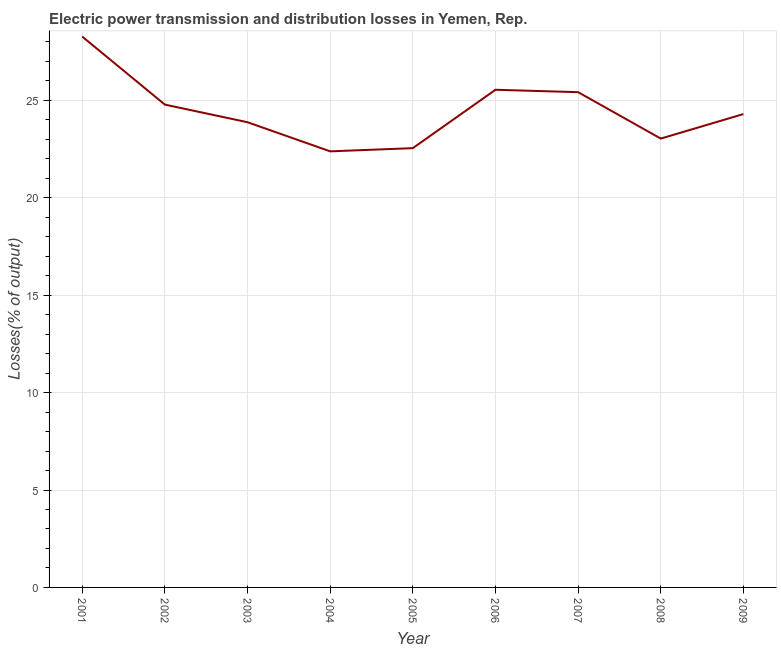What is the electric power transmission and distribution losses in 2003?
Your answer should be very brief. 23.88. Across all years, what is the maximum electric power transmission and distribution losses?
Provide a short and direct response. 28.27. Across all years, what is the minimum electric power transmission and distribution losses?
Offer a very short reply. 22.38. In which year was the electric power transmission and distribution losses minimum?
Your answer should be compact. 2004. What is the sum of the electric power transmission and distribution losses?
Make the answer very short. 220.15. What is the difference between the electric power transmission and distribution losses in 2002 and 2008?
Your response must be concise. 1.74. What is the average electric power transmission and distribution losses per year?
Provide a succinct answer. 24.46. What is the median electric power transmission and distribution losses?
Your answer should be very brief. 24.3. In how many years, is the electric power transmission and distribution losses greater than 19 %?
Provide a short and direct response. 9. What is the ratio of the electric power transmission and distribution losses in 2002 to that in 2006?
Your response must be concise. 0.97. What is the difference between the highest and the second highest electric power transmission and distribution losses?
Your answer should be very brief. 2.73. What is the difference between the highest and the lowest electric power transmission and distribution losses?
Keep it short and to the point. 5.89. In how many years, is the electric power transmission and distribution losses greater than the average electric power transmission and distribution losses taken over all years?
Keep it short and to the point. 4. Does the electric power transmission and distribution losses monotonically increase over the years?
Provide a short and direct response. No. How many lines are there?
Give a very brief answer. 1. How many years are there in the graph?
Your answer should be compact. 9. What is the difference between two consecutive major ticks on the Y-axis?
Your answer should be very brief. 5. Are the values on the major ticks of Y-axis written in scientific E-notation?
Provide a short and direct response. No. Does the graph contain any zero values?
Your response must be concise. No. What is the title of the graph?
Your answer should be compact. Electric power transmission and distribution losses in Yemen, Rep. What is the label or title of the Y-axis?
Give a very brief answer. Losses(% of output). What is the Losses(% of output) in 2001?
Ensure brevity in your answer.  28.27. What is the Losses(% of output) of 2002?
Provide a succinct answer. 24.78. What is the Losses(% of output) of 2003?
Your answer should be very brief. 23.88. What is the Losses(% of output) in 2004?
Keep it short and to the point. 22.38. What is the Losses(% of output) in 2005?
Keep it short and to the point. 22.55. What is the Losses(% of output) of 2006?
Provide a succinct answer. 25.54. What is the Losses(% of output) of 2007?
Provide a short and direct response. 25.42. What is the Losses(% of output) of 2008?
Offer a very short reply. 23.04. What is the Losses(% of output) of 2009?
Give a very brief answer. 24.3. What is the difference between the Losses(% of output) in 2001 and 2002?
Provide a succinct answer. 3.49. What is the difference between the Losses(% of output) in 2001 and 2003?
Offer a very short reply. 4.4. What is the difference between the Losses(% of output) in 2001 and 2004?
Your response must be concise. 5.89. What is the difference between the Losses(% of output) in 2001 and 2005?
Offer a very short reply. 5.73. What is the difference between the Losses(% of output) in 2001 and 2006?
Keep it short and to the point. 2.73. What is the difference between the Losses(% of output) in 2001 and 2007?
Provide a succinct answer. 2.85. What is the difference between the Losses(% of output) in 2001 and 2008?
Offer a very short reply. 5.24. What is the difference between the Losses(% of output) in 2001 and 2009?
Your answer should be compact. 3.98. What is the difference between the Losses(% of output) in 2002 and 2003?
Give a very brief answer. 0.9. What is the difference between the Losses(% of output) in 2002 and 2004?
Ensure brevity in your answer.  2.4. What is the difference between the Losses(% of output) in 2002 and 2005?
Provide a succinct answer. 2.23. What is the difference between the Losses(% of output) in 2002 and 2006?
Offer a very short reply. -0.76. What is the difference between the Losses(% of output) in 2002 and 2007?
Your answer should be very brief. -0.64. What is the difference between the Losses(% of output) in 2002 and 2008?
Provide a succinct answer. 1.74. What is the difference between the Losses(% of output) in 2002 and 2009?
Provide a succinct answer. 0.49. What is the difference between the Losses(% of output) in 2003 and 2004?
Offer a terse response. 1.49. What is the difference between the Losses(% of output) in 2003 and 2005?
Offer a terse response. 1.33. What is the difference between the Losses(% of output) in 2003 and 2006?
Provide a succinct answer. -1.67. What is the difference between the Losses(% of output) in 2003 and 2007?
Ensure brevity in your answer.  -1.54. What is the difference between the Losses(% of output) in 2003 and 2008?
Make the answer very short. 0.84. What is the difference between the Losses(% of output) in 2003 and 2009?
Provide a short and direct response. -0.42. What is the difference between the Losses(% of output) in 2004 and 2005?
Your answer should be very brief. -0.16. What is the difference between the Losses(% of output) in 2004 and 2006?
Keep it short and to the point. -3.16. What is the difference between the Losses(% of output) in 2004 and 2007?
Your response must be concise. -3.04. What is the difference between the Losses(% of output) in 2004 and 2008?
Your answer should be very brief. -0.65. What is the difference between the Losses(% of output) in 2004 and 2009?
Your response must be concise. -1.91. What is the difference between the Losses(% of output) in 2005 and 2006?
Offer a very short reply. -3. What is the difference between the Losses(% of output) in 2005 and 2007?
Your answer should be very brief. -2.87. What is the difference between the Losses(% of output) in 2005 and 2008?
Give a very brief answer. -0.49. What is the difference between the Losses(% of output) in 2005 and 2009?
Your answer should be compact. -1.75. What is the difference between the Losses(% of output) in 2006 and 2007?
Keep it short and to the point. 0.12. What is the difference between the Losses(% of output) in 2006 and 2008?
Offer a terse response. 2.51. What is the difference between the Losses(% of output) in 2006 and 2009?
Offer a terse response. 1.25. What is the difference between the Losses(% of output) in 2007 and 2008?
Provide a short and direct response. 2.38. What is the difference between the Losses(% of output) in 2007 and 2009?
Provide a succinct answer. 1.12. What is the difference between the Losses(% of output) in 2008 and 2009?
Keep it short and to the point. -1.26. What is the ratio of the Losses(% of output) in 2001 to that in 2002?
Ensure brevity in your answer.  1.14. What is the ratio of the Losses(% of output) in 2001 to that in 2003?
Your answer should be very brief. 1.18. What is the ratio of the Losses(% of output) in 2001 to that in 2004?
Provide a succinct answer. 1.26. What is the ratio of the Losses(% of output) in 2001 to that in 2005?
Your response must be concise. 1.25. What is the ratio of the Losses(% of output) in 2001 to that in 2006?
Provide a succinct answer. 1.11. What is the ratio of the Losses(% of output) in 2001 to that in 2007?
Provide a short and direct response. 1.11. What is the ratio of the Losses(% of output) in 2001 to that in 2008?
Give a very brief answer. 1.23. What is the ratio of the Losses(% of output) in 2001 to that in 2009?
Offer a terse response. 1.16. What is the ratio of the Losses(% of output) in 2002 to that in 2003?
Provide a succinct answer. 1.04. What is the ratio of the Losses(% of output) in 2002 to that in 2004?
Offer a terse response. 1.11. What is the ratio of the Losses(% of output) in 2002 to that in 2005?
Ensure brevity in your answer.  1.1. What is the ratio of the Losses(% of output) in 2002 to that in 2008?
Provide a short and direct response. 1.08. What is the ratio of the Losses(% of output) in 2003 to that in 2004?
Provide a succinct answer. 1.07. What is the ratio of the Losses(% of output) in 2003 to that in 2005?
Make the answer very short. 1.06. What is the ratio of the Losses(% of output) in 2003 to that in 2006?
Your response must be concise. 0.94. What is the ratio of the Losses(% of output) in 2003 to that in 2007?
Make the answer very short. 0.94. What is the ratio of the Losses(% of output) in 2003 to that in 2008?
Offer a very short reply. 1.04. What is the ratio of the Losses(% of output) in 2003 to that in 2009?
Ensure brevity in your answer.  0.98. What is the ratio of the Losses(% of output) in 2004 to that in 2006?
Provide a succinct answer. 0.88. What is the ratio of the Losses(% of output) in 2004 to that in 2007?
Ensure brevity in your answer.  0.88. What is the ratio of the Losses(% of output) in 2004 to that in 2008?
Your answer should be compact. 0.97. What is the ratio of the Losses(% of output) in 2004 to that in 2009?
Give a very brief answer. 0.92. What is the ratio of the Losses(% of output) in 2005 to that in 2006?
Make the answer very short. 0.88. What is the ratio of the Losses(% of output) in 2005 to that in 2007?
Offer a very short reply. 0.89. What is the ratio of the Losses(% of output) in 2005 to that in 2009?
Your answer should be compact. 0.93. What is the ratio of the Losses(% of output) in 2006 to that in 2007?
Provide a short and direct response. 1. What is the ratio of the Losses(% of output) in 2006 to that in 2008?
Provide a succinct answer. 1.11. What is the ratio of the Losses(% of output) in 2006 to that in 2009?
Keep it short and to the point. 1.05. What is the ratio of the Losses(% of output) in 2007 to that in 2008?
Your answer should be compact. 1.1. What is the ratio of the Losses(% of output) in 2007 to that in 2009?
Your answer should be compact. 1.05. What is the ratio of the Losses(% of output) in 2008 to that in 2009?
Make the answer very short. 0.95. 